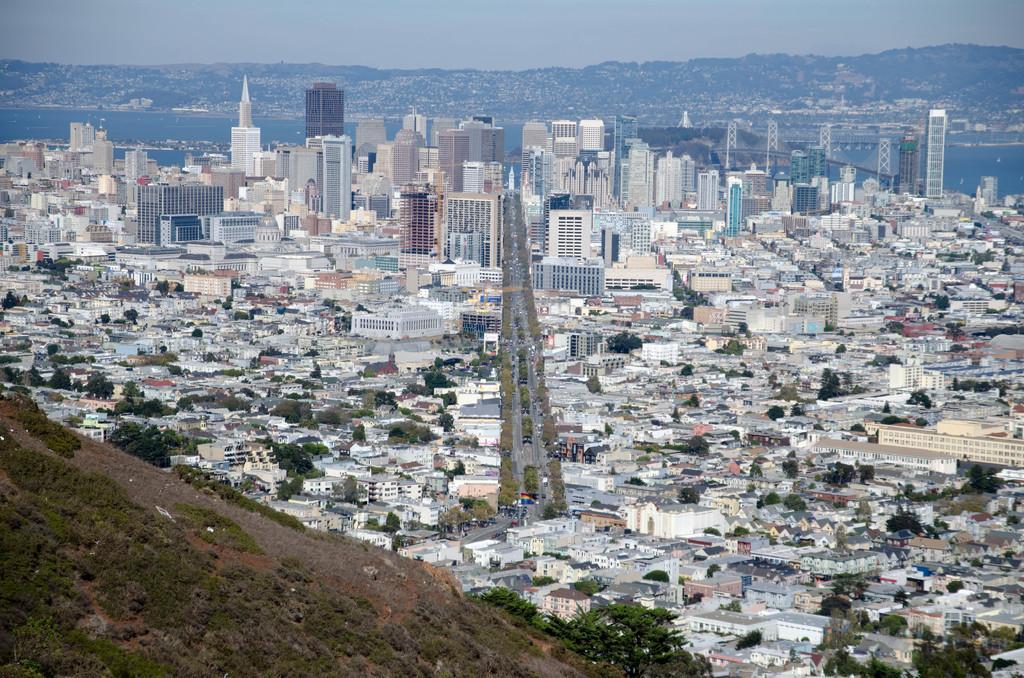Can you describe this image briefly? In the picture we can see a hill with grass and plants from it we can see a Aerial view of city with houses, buildings, trees, roads with vehicles on it and in the background we can see tower buildings, hills and sky. 